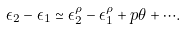Convert formula to latex. <formula><loc_0><loc_0><loc_500><loc_500>\epsilon _ { 2 } - \epsilon _ { 1 } \simeq \epsilon _ { 2 } ^ { \rho } - \epsilon _ { 1 } ^ { \rho } + p \theta + \cdots .</formula> 